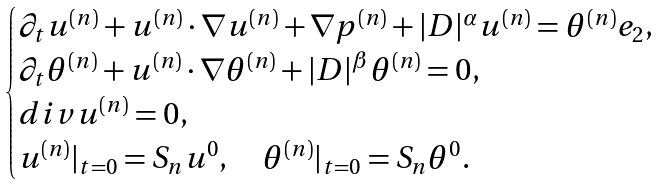<formula> <loc_0><loc_0><loc_500><loc_500>\begin{cases} \partial _ { t } u ^ { ( n ) } + u ^ { ( n ) } \cdot \nabla u ^ { ( n ) } + \nabla p ^ { ( n ) } + | D | ^ { \alpha } u ^ { ( n ) } = \theta ^ { ( n ) } e _ { 2 } , \\ \partial _ { t } \theta ^ { ( n ) } + u ^ { ( n ) } \cdot \nabla \theta ^ { ( n ) } + | D | ^ { \beta } \theta ^ { ( n ) } = 0 , \\ d i v u ^ { ( n ) } = 0 , \\ u ^ { ( n ) } | _ { t = 0 } = S _ { n } u ^ { 0 } , \quad \theta ^ { ( n ) } | _ { t = 0 } = S _ { n } \theta ^ { 0 } . \end{cases}</formula> 